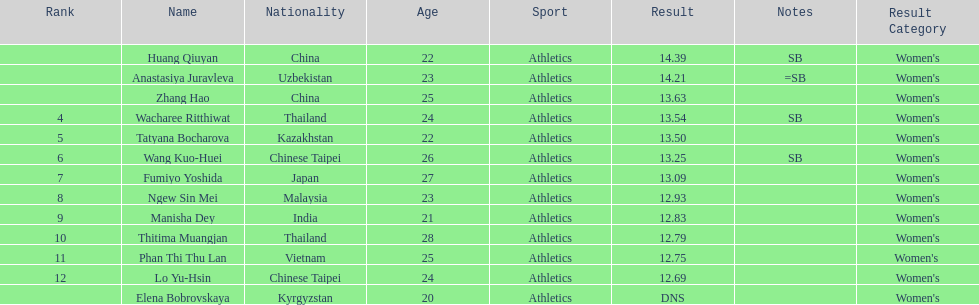What nationality was the woman who won first place? China. 